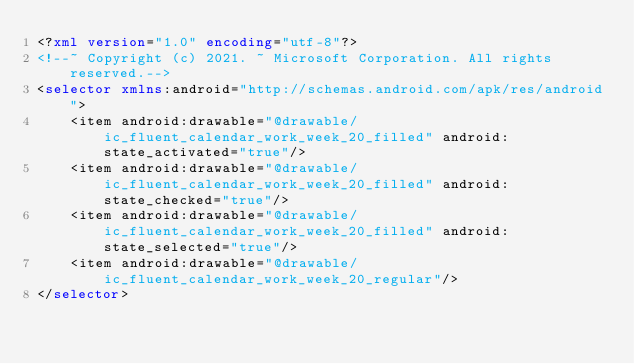<code> <loc_0><loc_0><loc_500><loc_500><_XML_><?xml version="1.0" encoding="utf-8"?>
<!--~ Copyright (c) 2021. ~ Microsoft Corporation. All rights reserved.-->
<selector xmlns:android="http://schemas.android.com/apk/res/android">
    <item android:drawable="@drawable/ic_fluent_calendar_work_week_20_filled" android:state_activated="true"/>
    <item android:drawable="@drawable/ic_fluent_calendar_work_week_20_filled" android:state_checked="true"/>
    <item android:drawable="@drawable/ic_fluent_calendar_work_week_20_filled" android:state_selected="true"/>
    <item android:drawable="@drawable/ic_fluent_calendar_work_week_20_regular"/>
</selector>
</code> 